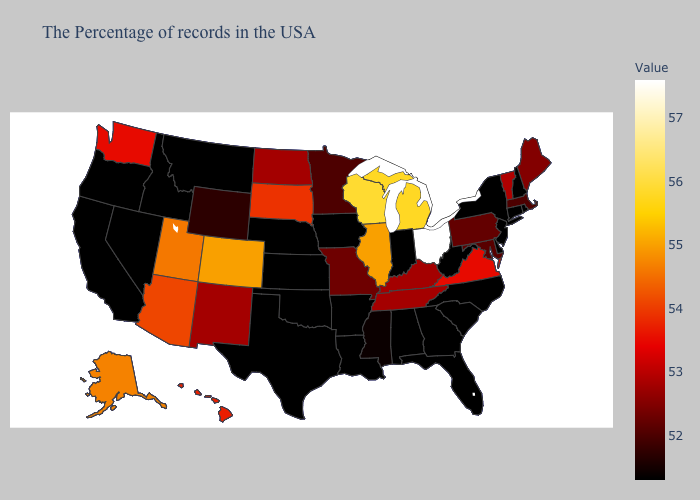Does North Dakota have the lowest value in the USA?
Concise answer only. No. Does Connecticut have the lowest value in the USA?
Write a very short answer. Yes. Does Virginia have the highest value in the South?
Answer briefly. Yes. Does New Mexico have the lowest value in the West?
Keep it brief. No. 